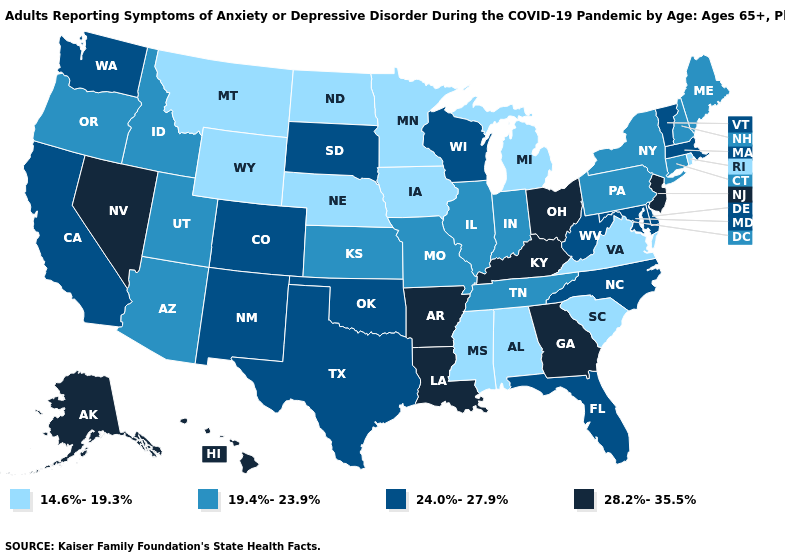What is the value of Georgia?
Keep it brief. 28.2%-35.5%. Name the states that have a value in the range 14.6%-19.3%?
Answer briefly. Alabama, Iowa, Michigan, Minnesota, Mississippi, Montana, Nebraska, North Dakota, Rhode Island, South Carolina, Virginia, Wyoming. What is the highest value in the Northeast ?
Write a very short answer. 28.2%-35.5%. Does Mississippi have the lowest value in the USA?
Short answer required. Yes. Name the states that have a value in the range 24.0%-27.9%?
Short answer required. California, Colorado, Delaware, Florida, Maryland, Massachusetts, New Mexico, North Carolina, Oklahoma, South Dakota, Texas, Vermont, Washington, West Virginia, Wisconsin. Name the states that have a value in the range 19.4%-23.9%?
Answer briefly. Arizona, Connecticut, Idaho, Illinois, Indiana, Kansas, Maine, Missouri, New Hampshire, New York, Oregon, Pennsylvania, Tennessee, Utah. Name the states that have a value in the range 19.4%-23.9%?
Concise answer only. Arizona, Connecticut, Idaho, Illinois, Indiana, Kansas, Maine, Missouri, New Hampshire, New York, Oregon, Pennsylvania, Tennessee, Utah. Is the legend a continuous bar?
Quick response, please. No. Name the states that have a value in the range 14.6%-19.3%?
Quick response, please. Alabama, Iowa, Michigan, Minnesota, Mississippi, Montana, Nebraska, North Dakota, Rhode Island, South Carolina, Virginia, Wyoming. Name the states that have a value in the range 19.4%-23.9%?
Quick response, please. Arizona, Connecticut, Idaho, Illinois, Indiana, Kansas, Maine, Missouri, New Hampshire, New York, Oregon, Pennsylvania, Tennessee, Utah. Does Texas have the lowest value in the USA?
Concise answer only. No. Name the states that have a value in the range 19.4%-23.9%?
Give a very brief answer. Arizona, Connecticut, Idaho, Illinois, Indiana, Kansas, Maine, Missouri, New Hampshire, New York, Oregon, Pennsylvania, Tennessee, Utah. Name the states that have a value in the range 19.4%-23.9%?
Write a very short answer. Arizona, Connecticut, Idaho, Illinois, Indiana, Kansas, Maine, Missouri, New Hampshire, New York, Oregon, Pennsylvania, Tennessee, Utah. Name the states that have a value in the range 19.4%-23.9%?
Keep it brief. Arizona, Connecticut, Idaho, Illinois, Indiana, Kansas, Maine, Missouri, New Hampshire, New York, Oregon, Pennsylvania, Tennessee, Utah. What is the highest value in the South ?
Write a very short answer. 28.2%-35.5%. 